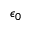<formula> <loc_0><loc_0><loc_500><loc_500>\epsilon _ { 0 }</formula> 